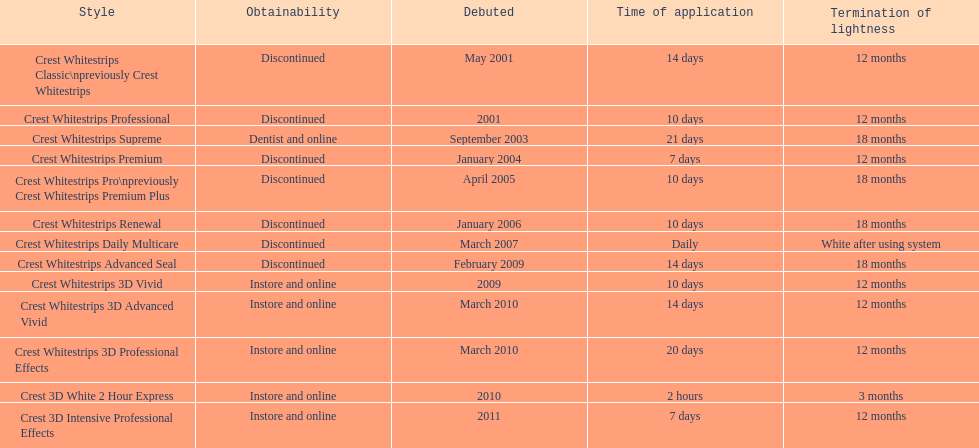Does the crest white strips classic last at least one year? Yes. 